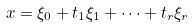<formula> <loc_0><loc_0><loc_500><loc_500>x = \xi _ { 0 } + t _ { 1 } \xi _ { 1 } + \cdots + t _ { r } \xi _ { r }</formula> 